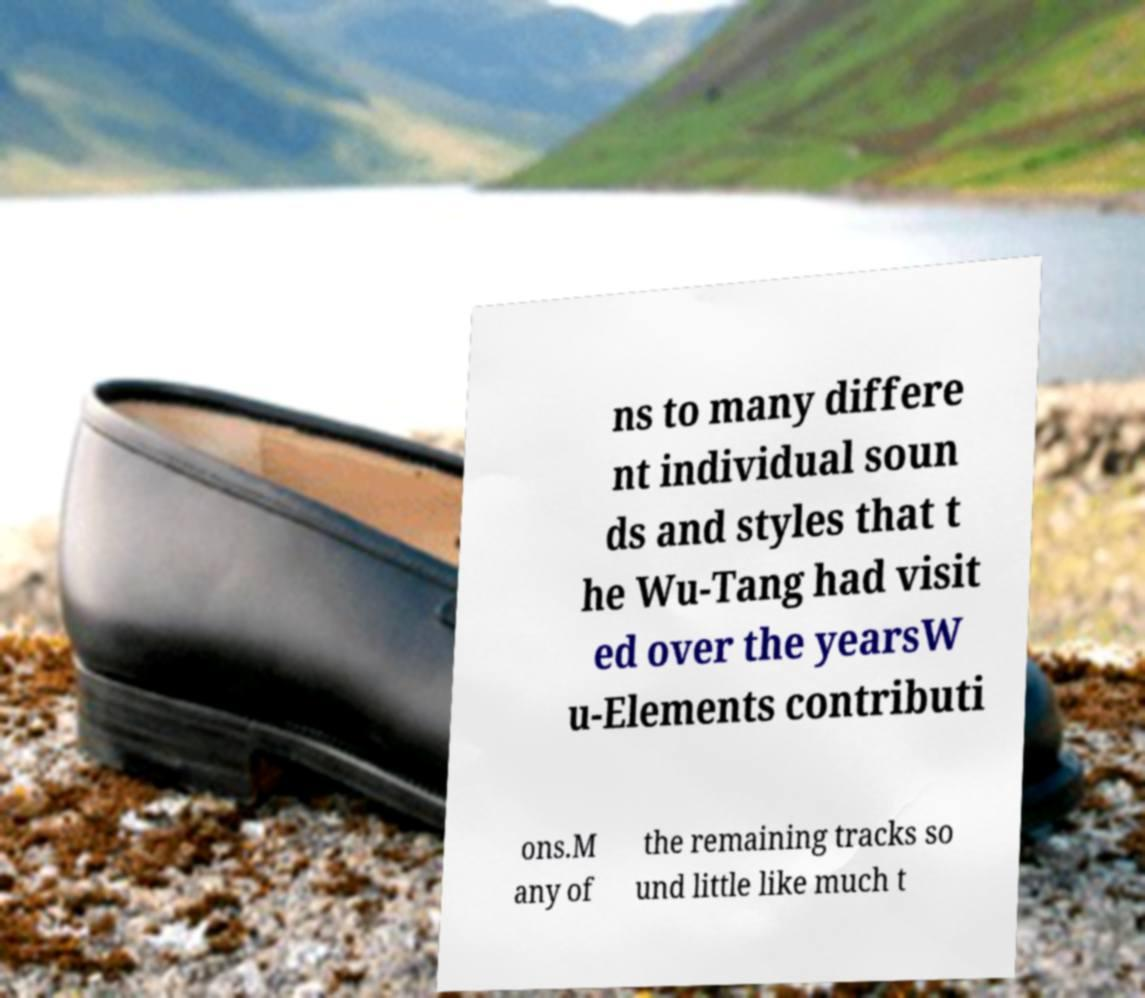What messages or text are displayed in this image? I need them in a readable, typed format. ns to many differe nt individual soun ds and styles that t he Wu-Tang had visit ed over the yearsW u-Elements contributi ons.M any of the remaining tracks so und little like much t 